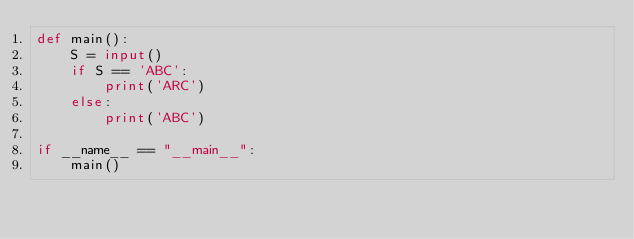<code> <loc_0><loc_0><loc_500><loc_500><_Python_>def main():
    S = input()
    if S == 'ABC':
        print('ARC')
    else:
        print('ABC')

if __name__ == "__main__":
    main()</code> 